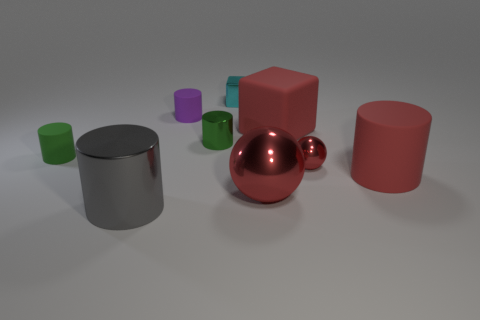What size is the rubber object that is the same color as the big rubber cylinder?
Keep it short and to the point. Large. Are there any rubber blocks that have the same color as the large sphere?
Ensure brevity in your answer.  Yes. Does the cube that is behind the big matte block have the same size as the green cylinder behind the green rubber object?
Make the answer very short. Yes. Is the number of big spheres on the left side of the large red cylinder greater than the number of shiny cylinders right of the large red rubber block?
Make the answer very short. Yes. Is there a small green thing made of the same material as the purple cylinder?
Your answer should be very brief. Yes. Is the color of the matte cube the same as the small metallic ball?
Ensure brevity in your answer.  Yes. There is a tiny cylinder that is in front of the purple thing and on the right side of the gray shiny cylinder; what is its material?
Provide a succinct answer. Metal. The big metal cylinder has what color?
Ensure brevity in your answer.  Gray. What number of purple things have the same shape as the big red metallic thing?
Give a very brief answer. 0. Are the tiny object that is to the right of the red matte cube and the small green object to the right of the gray metallic cylinder made of the same material?
Your answer should be compact. Yes. 